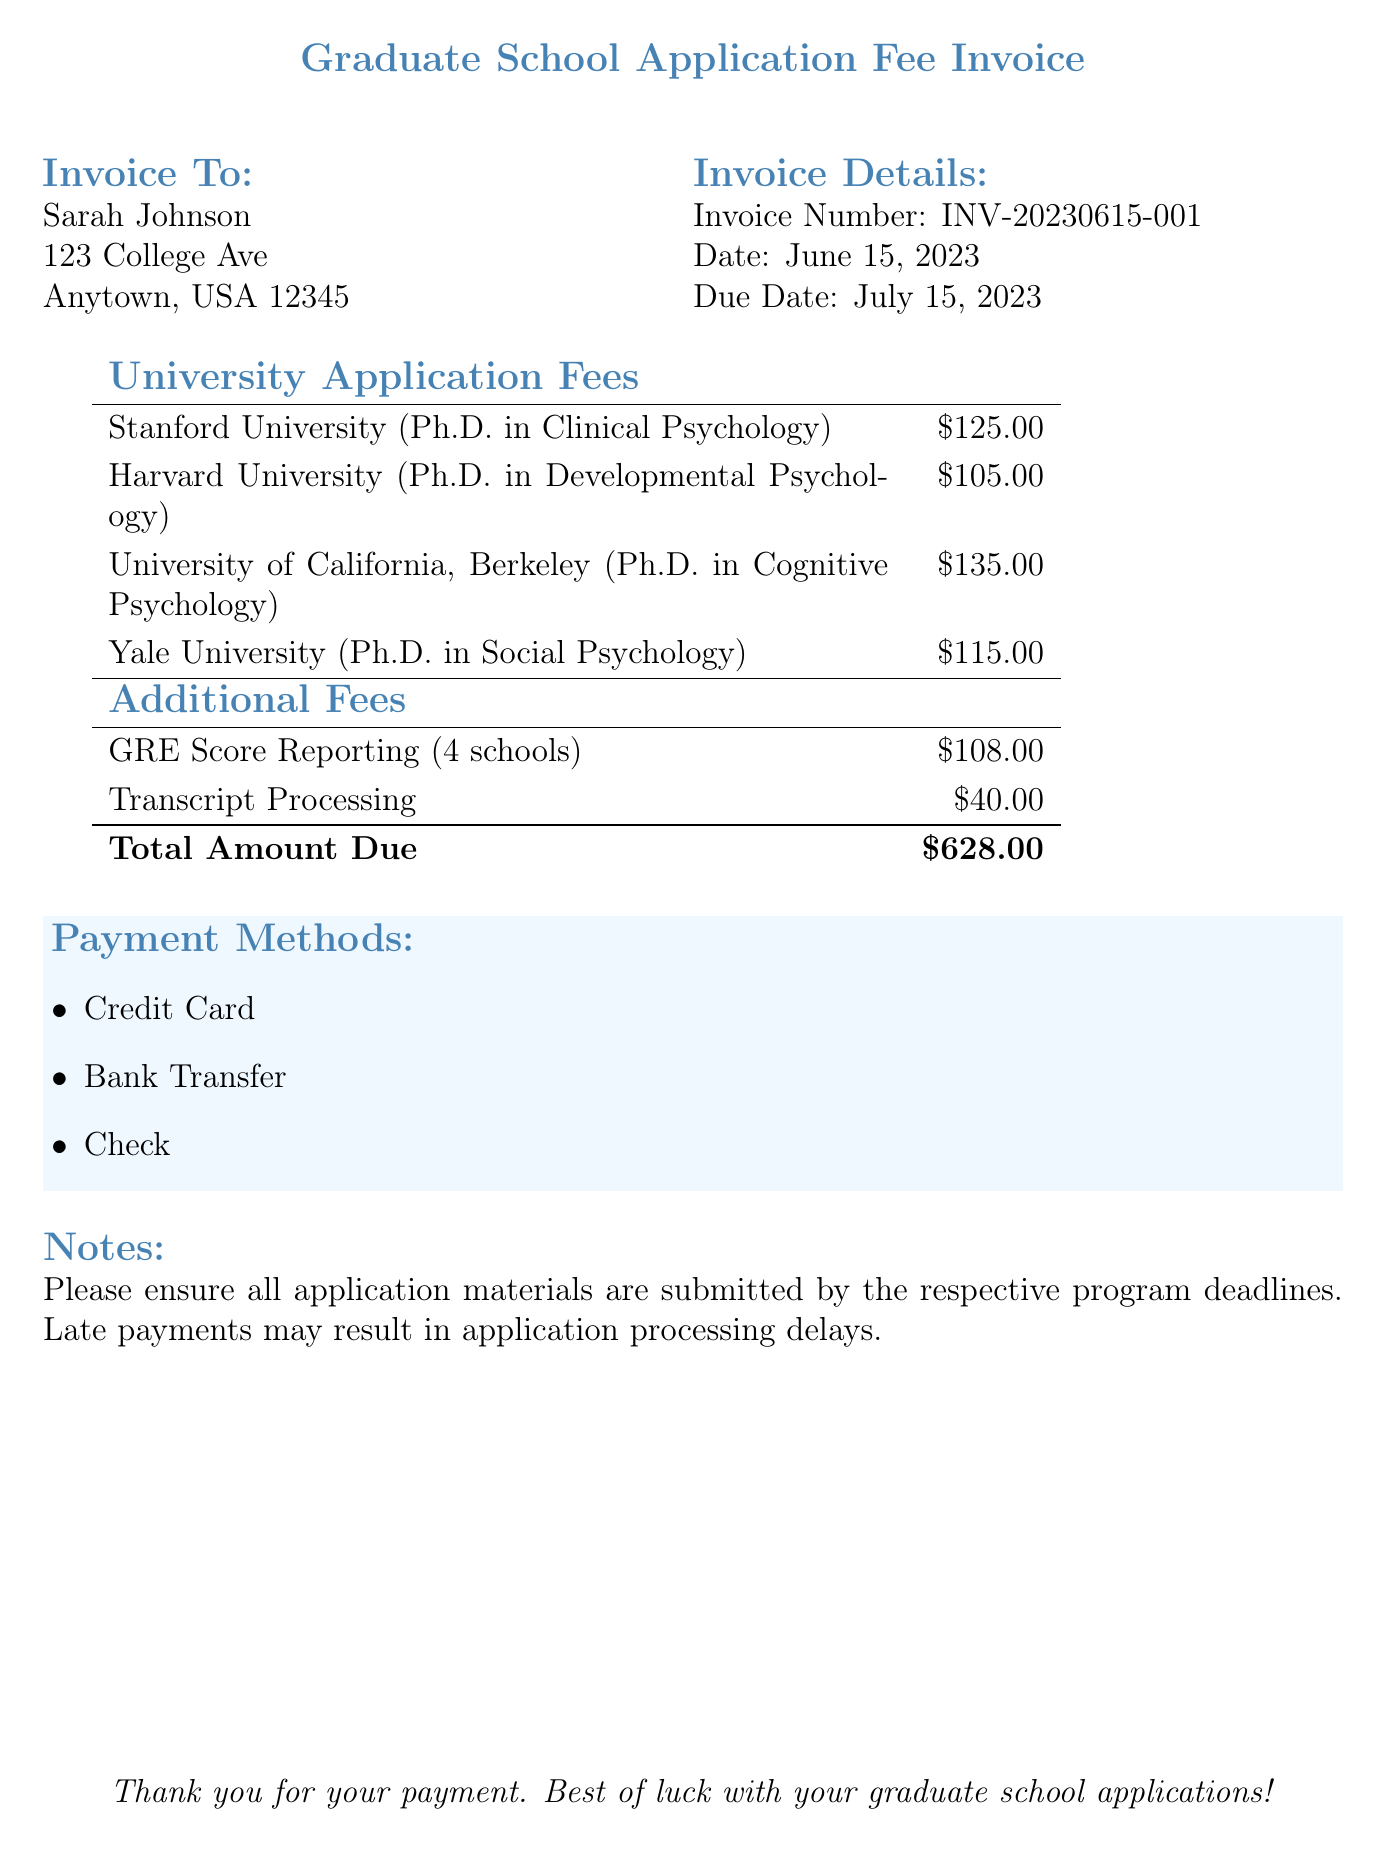What is the total amount due? The total amount due is the sum of all university application fees and additional fees listed in the invoice, which totals to $628.00.
Answer: $628.00 Which university charges the highest application fee? The highest application fee can be found by comparing each university's fee; in this case, it's the University of California, Berkeley at $135.00.
Answer: University of California, Berkeley What is the invoice number? The invoice number is a unique identifier for this document, which is listed as INV-20230615-001.
Answer: INV-20230615-001 When is the due date for this invoice? The due date is specified in the invoice details, which states it is July 15, 2023.
Answer: July 15, 2023 How much do GRE score reporting fees cost? The cost of GRE score reporting is provided as an additional fee, which totals $108.00.
Answer: $108.00 Who is the invoice addressed to? The name at the top of the invoice indicates the person to whom it is addressed, which is Sarah Johnson.
Answer: Sarah Johnson Which payment method is NOT listed in the invoice? The invoice mentions specific payment methods available for payment; if a method is not mentioned, such as PayPal, it can be identified.
Answer: PayPal What is the application fee for Harvard University? The application fee for Harvard University is explicitly mentioned in the list of university application fees, which is $105.00.
Answer: $105.00 What is the total of university application fees alone? The total of university application fees is the sum of all individual fees listed for each university, which equals $480.00.
Answer: $480.00 